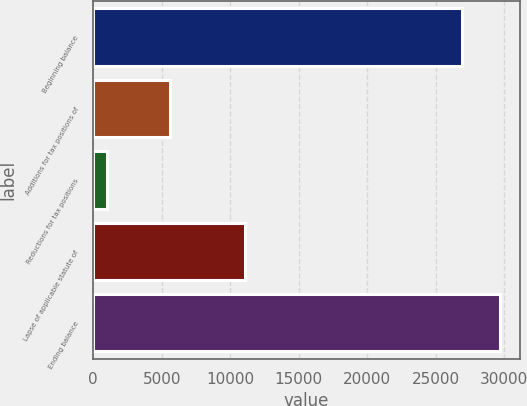Convert chart to OTSL. <chart><loc_0><loc_0><loc_500><loc_500><bar_chart><fcel>Beginning balance<fcel>Additions for tax positions of<fcel>Reductions for tax positions<fcel>Lapse of applicable statute of<fcel>Ending balance<nl><fcel>26924<fcel>5571<fcel>1008<fcel>11082.8<fcel>29679.9<nl></chart> 